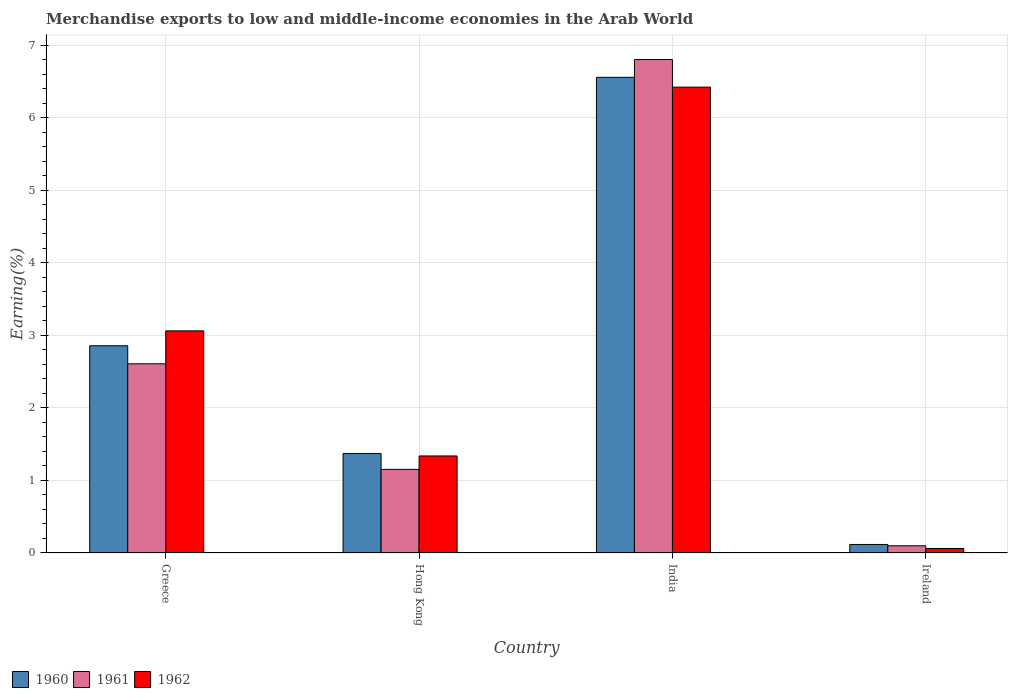How many different coloured bars are there?
Your response must be concise. 3. Are the number of bars per tick equal to the number of legend labels?
Your response must be concise. Yes. Are the number of bars on each tick of the X-axis equal?
Offer a terse response. Yes. How many bars are there on the 4th tick from the right?
Keep it short and to the point. 3. What is the percentage of amount earned from merchandise exports in 1960 in Greece?
Your response must be concise. 2.86. Across all countries, what is the maximum percentage of amount earned from merchandise exports in 1961?
Provide a short and direct response. 6.8. Across all countries, what is the minimum percentage of amount earned from merchandise exports in 1961?
Offer a terse response. 0.1. In which country was the percentage of amount earned from merchandise exports in 1961 maximum?
Make the answer very short. India. In which country was the percentage of amount earned from merchandise exports in 1960 minimum?
Keep it short and to the point. Ireland. What is the total percentage of amount earned from merchandise exports in 1961 in the graph?
Keep it short and to the point. 10.66. What is the difference between the percentage of amount earned from merchandise exports in 1961 in Greece and that in India?
Your answer should be very brief. -4.19. What is the difference between the percentage of amount earned from merchandise exports in 1962 in India and the percentage of amount earned from merchandise exports in 1961 in Hong Kong?
Provide a short and direct response. 5.27. What is the average percentage of amount earned from merchandise exports in 1961 per country?
Provide a succinct answer. 2.66. What is the difference between the percentage of amount earned from merchandise exports of/in 1962 and percentage of amount earned from merchandise exports of/in 1961 in Ireland?
Your answer should be very brief. -0.04. In how many countries, is the percentage of amount earned from merchandise exports in 1961 greater than 4.4 %?
Keep it short and to the point. 1. What is the ratio of the percentage of amount earned from merchandise exports in 1962 in Hong Kong to that in Ireland?
Make the answer very short. 21.69. Is the difference between the percentage of amount earned from merchandise exports in 1962 in Hong Kong and India greater than the difference between the percentage of amount earned from merchandise exports in 1961 in Hong Kong and India?
Provide a succinct answer. Yes. What is the difference between the highest and the second highest percentage of amount earned from merchandise exports in 1961?
Provide a succinct answer. -1.45. What is the difference between the highest and the lowest percentage of amount earned from merchandise exports in 1962?
Make the answer very short. 6.36. In how many countries, is the percentage of amount earned from merchandise exports in 1961 greater than the average percentage of amount earned from merchandise exports in 1961 taken over all countries?
Provide a succinct answer. 1. Is it the case that in every country, the sum of the percentage of amount earned from merchandise exports in 1960 and percentage of amount earned from merchandise exports in 1962 is greater than the percentage of amount earned from merchandise exports in 1961?
Provide a succinct answer. Yes. Are all the bars in the graph horizontal?
Keep it short and to the point. No. What is the difference between two consecutive major ticks on the Y-axis?
Offer a very short reply. 1. Are the values on the major ticks of Y-axis written in scientific E-notation?
Your answer should be very brief. No. Does the graph contain any zero values?
Your answer should be compact. No. Where does the legend appear in the graph?
Ensure brevity in your answer.  Bottom left. How many legend labels are there?
Offer a terse response. 3. How are the legend labels stacked?
Offer a terse response. Horizontal. What is the title of the graph?
Your answer should be compact. Merchandise exports to low and middle-income economies in the Arab World. Does "1985" appear as one of the legend labels in the graph?
Your response must be concise. No. What is the label or title of the Y-axis?
Ensure brevity in your answer.  Earning(%). What is the Earning(%) in 1960 in Greece?
Provide a short and direct response. 2.86. What is the Earning(%) of 1961 in Greece?
Offer a terse response. 2.61. What is the Earning(%) of 1962 in Greece?
Keep it short and to the point. 3.06. What is the Earning(%) of 1960 in Hong Kong?
Offer a very short reply. 1.37. What is the Earning(%) in 1961 in Hong Kong?
Make the answer very short. 1.15. What is the Earning(%) of 1962 in Hong Kong?
Provide a short and direct response. 1.34. What is the Earning(%) of 1960 in India?
Your answer should be very brief. 6.56. What is the Earning(%) in 1961 in India?
Offer a terse response. 6.8. What is the Earning(%) in 1962 in India?
Provide a succinct answer. 6.42. What is the Earning(%) of 1960 in Ireland?
Your answer should be compact. 0.12. What is the Earning(%) in 1961 in Ireland?
Provide a short and direct response. 0.1. What is the Earning(%) in 1962 in Ireland?
Keep it short and to the point. 0.06. Across all countries, what is the maximum Earning(%) in 1960?
Provide a short and direct response. 6.56. Across all countries, what is the maximum Earning(%) in 1961?
Your response must be concise. 6.8. Across all countries, what is the maximum Earning(%) of 1962?
Offer a very short reply. 6.42. Across all countries, what is the minimum Earning(%) in 1960?
Offer a terse response. 0.12. Across all countries, what is the minimum Earning(%) in 1961?
Provide a short and direct response. 0.1. Across all countries, what is the minimum Earning(%) in 1962?
Your answer should be very brief. 0.06. What is the total Earning(%) of 1960 in the graph?
Ensure brevity in your answer.  10.9. What is the total Earning(%) in 1961 in the graph?
Keep it short and to the point. 10.66. What is the total Earning(%) of 1962 in the graph?
Make the answer very short. 10.88. What is the difference between the Earning(%) of 1960 in Greece and that in Hong Kong?
Provide a succinct answer. 1.48. What is the difference between the Earning(%) in 1961 in Greece and that in Hong Kong?
Ensure brevity in your answer.  1.45. What is the difference between the Earning(%) in 1962 in Greece and that in Hong Kong?
Provide a succinct answer. 1.72. What is the difference between the Earning(%) of 1960 in Greece and that in India?
Make the answer very short. -3.7. What is the difference between the Earning(%) of 1961 in Greece and that in India?
Your answer should be very brief. -4.19. What is the difference between the Earning(%) of 1962 in Greece and that in India?
Provide a succinct answer. -3.36. What is the difference between the Earning(%) of 1960 in Greece and that in Ireland?
Ensure brevity in your answer.  2.74. What is the difference between the Earning(%) in 1961 in Greece and that in Ireland?
Give a very brief answer. 2.51. What is the difference between the Earning(%) of 1962 in Greece and that in Ireland?
Offer a terse response. 3. What is the difference between the Earning(%) of 1960 in Hong Kong and that in India?
Your response must be concise. -5.18. What is the difference between the Earning(%) in 1961 in Hong Kong and that in India?
Your response must be concise. -5.65. What is the difference between the Earning(%) in 1962 in Hong Kong and that in India?
Your answer should be very brief. -5.08. What is the difference between the Earning(%) of 1960 in Hong Kong and that in Ireland?
Keep it short and to the point. 1.25. What is the difference between the Earning(%) in 1961 in Hong Kong and that in Ireland?
Make the answer very short. 1.05. What is the difference between the Earning(%) of 1962 in Hong Kong and that in Ireland?
Keep it short and to the point. 1.28. What is the difference between the Earning(%) in 1960 in India and that in Ireland?
Provide a succinct answer. 6.44. What is the difference between the Earning(%) of 1961 in India and that in Ireland?
Offer a very short reply. 6.7. What is the difference between the Earning(%) in 1962 in India and that in Ireland?
Your answer should be compact. 6.36. What is the difference between the Earning(%) of 1960 in Greece and the Earning(%) of 1961 in Hong Kong?
Provide a succinct answer. 1.7. What is the difference between the Earning(%) in 1960 in Greece and the Earning(%) in 1962 in Hong Kong?
Make the answer very short. 1.52. What is the difference between the Earning(%) in 1961 in Greece and the Earning(%) in 1962 in Hong Kong?
Your answer should be compact. 1.27. What is the difference between the Earning(%) in 1960 in Greece and the Earning(%) in 1961 in India?
Offer a terse response. -3.94. What is the difference between the Earning(%) in 1960 in Greece and the Earning(%) in 1962 in India?
Offer a very short reply. -3.56. What is the difference between the Earning(%) of 1961 in Greece and the Earning(%) of 1962 in India?
Offer a terse response. -3.81. What is the difference between the Earning(%) of 1960 in Greece and the Earning(%) of 1961 in Ireland?
Offer a terse response. 2.76. What is the difference between the Earning(%) of 1960 in Greece and the Earning(%) of 1962 in Ireland?
Offer a very short reply. 2.79. What is the difference between the Earning(%) of 1961 in Greece and the Earning(%) of 1962 in Ireland?
Give a very brief answer. 2.55. What is the difference between the Earning(%) of 1960 in Hong Kong and the Earning(%) of 1961 in India?
Make the answer very short. -5.43. What is the difference between the Earning(%) of 1960 in Hong Kong and the Earning(%) of 1962 in India?
Offer a very short reply. -5.05. What is the difference between the Earning(%) in 1961 in Hong Kong and the Earning(%) in 1962 in India?
Your answer should be very brief. -5.27. What is the difference between the Earning(%) of 1960 in Hong Kong and the Earning(%) of 1961 in Ireland?
Give a very brief answer. 1.27. What is the difference between the Earning(%) of 1960 in Hong Kong and the Earning(%) of 1962 in Ireland?
Provide a succinct answer. 1.31. What is the difference between the Earning(%) in 1961 in Hong Kong and the Earning(%) in 1962 in Ireland?
Your answer should be very brief. 1.09. What is the difference between the Earning(%) of 1960 in India and the Earning(%) of 1961 in Ireland?
Provide a short and direct response. 6.46. What is the difference between the Earning(%) of 1960 in India and the Earning(%) of 1962 in Ireland?
Your answer should be very brief. 6.49. What is the difference between the Earning(%) in 1961 in India and the Earning(%) in 1962 in Ireland?
Offer a very short reply. 6.74. What is the average Earning(%) of 1960 per country?
Your response must be concise. 2.72. What is the average Earning(%) in 1961 per country?
Make the answer very short. 2.66. What is the average Earning(%) in 1962 per country?
Give a very brief answer. 2.72. What is the difference between the Earning(%) in 1960 and Earning(%) in 1961 in Greece?
Provide a short and direct response. 0.25. What is the difference between the Earning(%) of 1960 and Earning(%) of 1962 in Greece?
Keep it short and to the point. -0.21. What is the difference between the Earning(%) in 1961 and Earning(%) in 1962 in Greece?
Offer a very short reply. -0.45. What is the difference between the Earning(%) of 1960 and Earning(%) of 1961 in Hong Kong?
Make the answer very short. 0.22. What is the difference between the Earning(%) of 1960 and Earning(%) of 1962 in Hong Kong?
Your response must be concise. 0.03. What is the difference between the Earning(%) of 1961 and Earning(%) of 1962 in Hong Kong?
Your answer should be compact. -0.18. What is the difference between the Earning(%) of 1960 and Earning(%) of 1961 in India?
Provide a short and direct response. -0.24. What is the difference between the Earning(%) in 1960 and Earning(%) in 1962 in India?
Offer a very short reply. 0.14. What is the difference between the Earning(%) of 1961 and Earning(%) of 1962 in India?
Ensure brevity in your answer.  0.38. What is the difference between the Earning(%) of 1960 and Earning(%) of 1961 in Ireland?
Provide a succinct answer. 0.02. What is the difference between the Earning(%) in 1960 and Earning(%) in 1962 in Ireland?
Offer a very short reply. 0.06. What is the difference between the Earning(%) of 1961 and Earning(%) of 1962 in Ireland?
Offer a very short reply. 0.04. What is the ratio of the Earning(%) of 1960 in Greece to that in Hong Kong?
Your answer should be very brief. 2.08. What is the ratio of the Earning(%) of 1961 in Greece to that in Hong Kong?
Ensure brevity in your answer.  2.26. What is the ratio of the Earning(%) in 1962 in Greece to that in Hong Kong?
Offer a terse response. 2.29. What is the ratio of the Earning(%) of 1960 in Greece to that in India?
Your answer should be very brief. 0.44. What is the ratio of the Earning(%) in 1961 in Greece to that in India?
Offer a very short reply. 0.38. What is the ratio of the Earning(%) in 1962 in Greece to that in India?
Ensure brevity in your answer.  0.48. What is the ratio of the Earning(%) of 1960 in Greece to that in Ireland?
Offer a terse response. 24.29. What is the ratio of the Earning(%) in 1961 in Greece to that in Ireland?
Ensure brevity in your answer.  26.29. What is the ratio of the Earning(%) in 1962 in Greece to that in Ireland?
Your answer should be very brief. 49.65. What is the ratio of the Earning(%) of 1960 in Hong Kong to that in India?
Keep it short and to the point. 0.21. What is the ratio of the Earning(%) in 1961 in Hong Kong to that in India?
Your answer should be compact. 0.17. What is the ratio of the Earning(%) of 1962 in Hong Kong to that in India?
Ensure brevity in your answer.  0.21. What is the ratio of the Earning(%) of 1960 in Hong Kong to that in Ireland?
Keep it short and to the point. 11.66. What is the ratio of the Earning(%) of 1961 in Hong Kong to that in Ireland?
Your answer should be compact. 11.62. What is the ratio of the Earning(%) of 1962 in Hong Kong to that in Ireland?
Provide a succinct answer. 21.69. What is the ratio of the Earning(%) of 1960 in India to that in Ireland?
Make the answer very short. 55.76. What is the ratio of the Earning(%) in 1961 in India to that in Ireland?
Provide a succinct answer. 68.57. What is the ratio of the Earning(%) of 1962 in India to that in Ireland?
Offer a very short reply. 104.13. What is the difference between the highest and the second highest Earning(%) of 1960?
Keep it short and to the point. 3.7. What is the difference between the highest and the second highest Earning(%) in 1961?
Give a very brief answer. 4.19. What is the difference between the highest and the second highest Earning(%) in 1962?
Give a very brief answer. 3.36. What is the difference between the highest and the lowest Earning(%) in 1960?
Offer a very short reply. 6.44. What is the difference between the highest and the lowest Earning(%) in 1961?
Make the answer very short. 6.7. What is the difference between the highest and the lowest Earning(%) in 1962?
Your answer should be very brief. 6.36. 